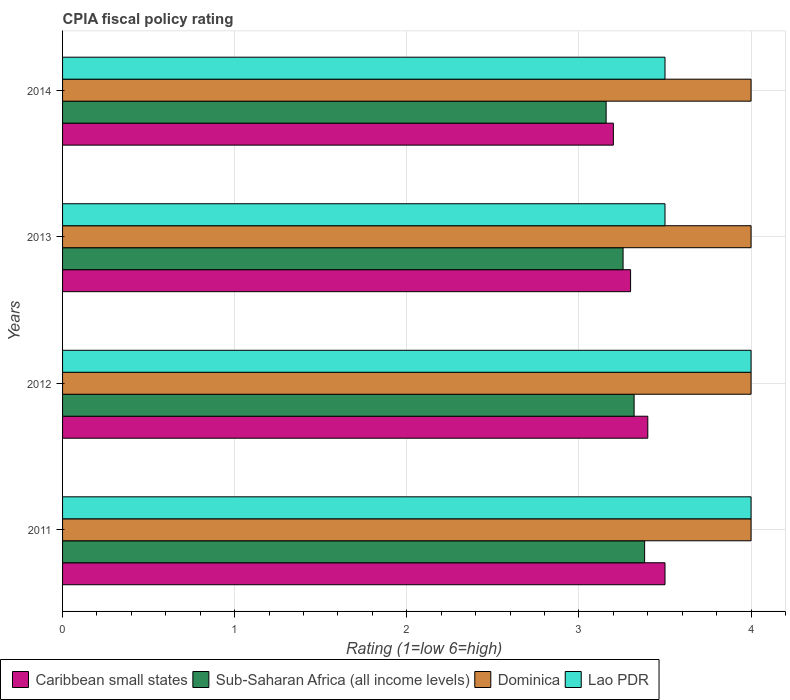How many different coloured bars are there?
Give a very brief answer. 4. Are the number of bars on each tick of the Y-axis equal?
Provide a succinct answer. Yes. How many bars are there on the 4th tick from the bottom?
Your response must be concise. 4. What is the CPIA rating in Sub-Saharan Africa (all income levels) in 2012?
Ensure brevity in your answer.  3.32. Across all years, what is the maximum CPIA rating in Lao PDR?
Your answer should be compact. 4. Across all years, what is the minimum CPIA rating in Dominica?
Your response must be concise. 4. In which year was the CPIA rating in Dominica minimum?
Keep it short and to the point. 2011. What is the difference between the CPIA rating in Caribbean small states in 2011 and that in 2013?
Give a very brief answer. 0.2. What is the difference between the CPIA rating in Caribbean small states in 2014 and the CPIA rating in Sub-Saharan Africa (all income levels) in 2013?
Provide a succinct answer. -0.06. In the year 2014, what is the difference between the CPIA rating in Lao PDR and CPIA rating in Caribbean small states?
Provide a succinct answer. 0.3. In how many years, is the CPIA rating in Lao PDR greater than 1.2 ?
Offer a very short reply. 4. What is the ratio of the CPIA rating in Caribbean small states in 2011 to that in 2013?
Your answer should be compact. 1.06. What is the difference between the highest and the second highest CPIA rating in Sub-Saharan Africa (all income levels)?
Provide a short and direct response. 0.06. Is the sum of the CPIA rating in Lao PDR in 2012 and 2014 greater than the maximum CPIA rating in Caribbean small states across all years?
Ensure brevity in your answer.  Yes. What does the 3rd bar from the top in 2013 represents?
Provide a succinct answer. Sub-Saharan Africa (all income levels). What does the 1st bar from the bottom in 2014 represents?
Ensure brevity in your answer.  Caribbean small states. How many bars are there?
Your answer should be very brief. 16. Does the graph contain any zero values?
Provide a succinct answer. No. Does the graph contain grids?
Offer a very short reply. Yes. How are the legend labels stacked?
Give a very brief answer. Horizontal. What is the title of the graph?
Your answer should be compact. CPIA fiscal policy rating. Does "Philippines" appear as one of the legend labels in the graph?
Your answer should be very brief. No. What is the Rating (1=low 6=high) of Sub-Saharan Africa (all income levels) in 2011?
Keep it short and to the point. 3.38. What is the Rating (1=low 6=high) in Sub-Saharan Africa (all income levels) in 2012?
Make the answer very short. 3.32. What is the Rating (1=low 6=high) in Sub-Saharan Africa (all income levels) in 2013?
Offer a terse response. 3.26. What is the Rating (1=low 6=high) in Dominica in 2013?
Your response must be concise. 4. What is the Rating (1=low 6=high) of Caribbean small states in 2014?
Provide a succinct answer. 3.2. What is the Rating (1=low 6=high) in Sub-Saharan Africa (all income levels) in 2014?
Your response must be concise. 3.16. What is the Rating (1=low 6=high) of Dominica in 2014?
Your response must be concise. 4. Across all years, what is the maximum Rating (1=low 6=high) of Caribbean small states?
Keep it short and to the point. 3.5. Across all years, what is the maximum Rating (1=low 6=high) of Sub-Saharan Africa (all income levels)?
Give a very brief answer. 3.38. Across all years, what is the maximum Rating (1=low 6=high) in Dominica?
Give a very brief answer. 4. Across all years, what is the maximum Rating (1=low 6=high) of Lao PDR?
Offer a very short reply. 4. Across all years, what is the minimum Rating (1=low 6=high) of Sub-Saharan Africa (all income levels)?
Make the answer very short. 3.16. Across all years, what is the minimum Rating (1=low 6=high) of Lao PDR?
Your response must be concise. 3.5. What is the total Rating (1=low 6=high) in Sub-Saharan Africa (all income levels) in the graph?
Give a very brief answer. 13.12. What is the total Rating (1=low 6=high) in Dominica in the graph?
Your answer should be very brief. 16. What is the total Rating (1=low 6=high) of Lao PDR in the graph?
Your response must be concise. 15. What is the difference between the Rating (1=low 6=high) of Caribbean small states in 2011 and that in 2012?
Offer a very short reply. 0.1. What is the difference between the Rating (1=low 6=high) of Sub-Saharan Africa (all income levels) in 2011 and that in 2012?
Provide a succinct answer. 0.06. What is the difference between the Rating (1=low 6=high) in Dominica in 2011 and that in 2012?
Your answer should be compact. 0. What is the difference between the Rating (1=low 6=high) in Sub-Saharan Africa (all income levels) in 2011 and that in 2013?
Give a very brief answer. 0.13. What is the difference between the Rating (1=low 6=high) in Dominica in 2011 and that in 2013?
Your answer should be compact. 0. What is the difference between the Rating (1=low 6=high) in Lao PDR in 2011 and that in 2013?
Offer a terse response. 0.5. What is the difference between the Rating (1=low 6=high) in Sub-Saharan Africa (all income levels) in 2011 and that in 2014?
Your answer should be compact. 0.22. What is the difference between the Rating (1=low 6=high) in Dominica in 2011 and that in 2014?
Make the answer very short. 0. What is the difference between the Rating (1=low 6=high) in Caribbean small states in 2012 and that in 2013?
Ensure brevity in your answer.  0.1. What is the difference between the Rating (1=low 6=high) of Sub-Saharan Africa (all income levels) in 2012 and that in 2013?
Offer a terse response. 0.06. What is the difference between the Rating (1=low 6=high) in Sub-Saharan Africa (all income levels) in 2012 and that in 2014?
Keep it short and to the point. 0.16. What is the difference between the Rating (1=low 6=high) of Sub-Saharan Africa (all income levels) in 2013 and that in 2014?
Provide a short and direct response. 0.1. What is the difference between the Rating (1=low 6=high) in Lao PDR in 2013 and that in 2014?
Offer a very short reply. 0. What is the difference between the Rating (1=low 6=high) of Caribbean small states in 2011 and the Rating (1=low 6=high) of Sub-Saharan Africa (all income levels) in 2012?
Give a very brief answer. 0.18. What is the difference between the Rating (1=low 6=high) in Caribbean small states in 2011 and the Rating (1=low 6=high) in Lao PDR in 2012?
Offer a very short reply. -0.5. What is the difference between the Rating (1=low 6=high) in Sub-Saharan Africa (all income levels) in 2011 and the Rating (1=low 6=high) in Dominica in 2012?
Offer a terse response. -0.62. What is the difference between the Rating (1=low 6=high) in Sub-Saharan Africa (all income levels) in 2011 and the Rating (1=low 6=high) in Lao PDR in 2012?
Your response must be concise. -0.62. What is the difference between the Rating (1=low 6=high) in Caribbean small states in 2011 and the Rating (1=low 6=high) in Sub-Saharan Africa (all income levels) in 2013?
Your answer should be very brief. 0.24. What is the difference between the Rating (1=low 6=high) in Caribbean small states in 2011 and the Rating (1=low 6=high) in Lao PDR in 2013?
Make the answer very short. 0. What is the difference between the Rating (1=low 6=high) of Sub-Saharan Africa (all income levels) in 2011 and the Rating (1=low 6=high) of Dominica in 2013?
Make the answer very short. -0.62. What is the difference between the Rating (1=low 6=high) in Sub-Saharan Africa (all income levels) in 2011 and the Rating (1=low 6=high) in Lao PDR in 2013?
Offer a terse response. -0.12. What is the difference between the Rating (1=low 6=high) in Caribbean small states in 2011 and the Rating (1=low 6=high) in Sub-Saharan Africa (all income levels) in 2014?
Ensure brevity in your answer.  0.34. What is the difference between the Rating (1=low 6=high) in Caribbean small states in 2011 and the Rating (1=low 6=high) in Lao PDR in 2014?
Give a very brief answer. 0. What is the difference between the Rating (1=low 6=high) of Sub-Saharan Africa (all income levels) in 2011 and the Rating (1=low 6=high) of Dominica in 2014?
Offer a very short reply. -0.62. What is the difference between the Rating (1=low 6=high) in Sub-Saharan Africa (all income levels) in 2011 and the Rating (1=low 6=high) in Lao PDR in 2014?
Provide a succinct answer. -0.12. What is the difference between the Rating (1=low 6=high) of Caribbean small states in 2012 and the Rating (1=low 6=high) of Sub-Saharan Africa (all income levels) in 2013?
Offer a terse response. 0.14. What is the difference between the Rating (1=low 6=high) of Caribbean small states in 2012 and the Rating (1=low 6=high) of Dominica in 2013?
Give a very brief answer. -0.6. What is the difference between the Rating (1=low 6=high) of Caribbean small states in 2012 and the Rating (1=low 6=high) of Lao PDR in 2013?
Ensure brevity in your answer.  -0.1. What is the difference between the Rating (1=low 6=high) of Sub-Saharan Africa (all income levels) in 2012 and the Rating (1=low 6=high) of Dominica in 2013?
Your answer should be compact. -0.68. What is the difference between the Rating (1=low 6=high) in Sub-Saharan Africa (all income levels) in 2012 and the Rating (1=low 6=high) in Lao PDR in 2013?
Give a very brief answer. -0.18. What is the difference between the Rating (1=low 6=high) in Dominica in 2012 and the Rating (1=low 6=high) in Lao PDR in 2013?
Make the answer very short. 0.5. What is the difference between the Rating (1=low 6=high) of Caribbean small states in 2012 and the Rating (1=low 6=high) of Sub-Saharan Africa (all income levels) in 2014?
Your answer should be compact. 0.24. What is the difference between the Rating (1=low 6=high) of Caribbean small states in 2012 and the Rating (1=low 6=high) of Lao PDR in 2014?
Your answer should be compact. -0.1. What is the difference between the Rating (1=low 6=high) of Sub-Saharan Africa (all income levels) in 2012 and the Rating (1=low 6=high) of Dominica in 2014?
Ensure brevity in your answer.  -0.68. What is the difference between the Rating (1=low 6=high) of Sub-Saharan Africa (all income levels) in 2012 and the Rating (1=low 6=high) of Lao PDR in 2014?
Your response must be concise. -0.18. What is the difference between the Rating (1=low 6=high) of Caribbean small states in 2013 and the Rating (1=low 6=high) of Sub-Saharan Africa (all income levels) in 2014?
Make the answer very short. 0.14. What is the difference between the Rating (1=low 6=high) in Caribbean small states in 2013 and the Rating (1=low 6=high) in Dominica in 2014?
Your answer should be very brief. -0.7. What is the difference between the Rating (1=low 6=high) of Caribbean small states in 2013 and the Rating (1=low 6=high) of Lao PDR in 2014?
Give a very brief answer. -0.2. What is the difference between the Rating (1=low 6=high) in Sub-Saharan Africa (all income levels) in 2013 and the Rating (1=low 6=high) in Dominica in 2014?
Your answer should be very brief. -0.74. What is the difference between the Rating (1=low 6=high) of Sub-Saharan Africa (all income levels) in 2013 and the Rating (1=low 6=high) of Lao PDR in 2014?
Keep it short and to the point. -0.24. What is the difference between the Rating (1=low 6=high) of Dominica in 2013 and the Rating (1=low 6=high) of Lao PDR in 2014?
Keep it short and to the point. 0.5. What is the average Rating (1=low 6=high) of Caribbean small states per year?
Make the answer very short. 3.35. What is the average Rating (1=low 6=high) of Sub-Saharan Africa (all income levels) per year?
Give a very brief answer. 3.28. What is the average Rating (1=low 6=high) in Lao PDR per year?
Offer a terse response. 3.75. In the year 2011, what is the difference between the Rating (1=low 6=high) in Caribbean small states and Rating (1=low 6=high) in Sub-Saharan Africa (all income levels)?
Keep it short and to the point. 0.12. In the year 2011, what is the difference between the Rating (1=low 6=high) of Sub-Saharan Africa (all income levels) and Rating (1=low 6=high) of Dominica?
Your answer should be very brief. -0.62. In the year 2011, what is the difference between the Rating (1=low 6=high) in Sub-Saharan Africa (all income levels) and Rating (1=low 6=high) in Lao PDR?
Keep it short and to the point. -0.62. In the year 2012, what is the difference between the Rating (1=low 6=high) in Caribbean small states and Rating (1=low 6=high) in Sub-Saharan Africa (all income levels)?
Offer a terse response. 0.08. In the year 2012, what is the difference between the Rating (1=low 6=high) in Caribbean small states and Rating (1=low 6=high) in Dominica?
Provide a succinct answer. -0.6. In the year 2012, what is the difference between the Rating (1=low 6=high) of Sub-Saharan Africa (all income levels) and Rating (1=low 6=high) of Dominica?
Provide a short and direct response. -0.68. In the year 2012, what is the difference between the Rating (1=low 6=high) in Sub-Saharan Africa (all income levels) and Rating (1=low 6=high) in Lao PDR?
Offer a terse response. -0.68. In the year 2012, what is the difference between the Rating (1=low 6=high) of Dominica and Rating (1=low 6=high) of Lao PDR?
Ensure brevity in your answer.  0. In the year 2013, what is the difference between the Rating (1=low 6=high) of Caribbean small states and Rating (1=low 6=high) of Sub-Saharan Africa (all income levels)?
Your answer should be compact. 0.04. In the year 2013, what is the difference between the Rating (1=low 6=high) in Caribbean small states and Rating (1=low 6=high) in Dominica?
Your answer should be very brief. -0.7. In the year 2013, what is the difference between the Rating (1=low 6=high) of Caribbean small states and Rating (1=low 6=high) of Lao PDR?
Offer a terse response. -0.2. In the year 2013, what is the difference between the Rating (1=low 6=high) in Sub-Saharan Africa (all income levels) and Rating (1=low 6=high) in Dominica?
Give a very brief answer. -0.74. In the year 2013, what is the difference between the Rating (1=low 6=high) in Sub-Saharan Africa (all income levels) and Rating (1=low 6=high) in Lao PDR?
Ensure brevity in your answer.  -0.24. In the year 2014, what is the difference between the Rating (1=low 6=high) in Caribbean small states and Rating (1=low 6=high) in Sub-Saharan Africa (all income levels)?
Offer a terse response. 0.04. In the year 2014, what is the difference between the Rating (1=low 6=high) of Caribbean small states and Rating (1=low 6=high) of Lao PDR?
Provide a succinct answer. -0.3. In the year 2014, what is the difference between the Rating (1=low 6=high) of Sub-Saharan Africa (all income levels) and Rating (1=low 6=high) of Dominica?
Offer a terse response. -0.84. In the year 2014, what is the difference between the Rating (1=low 6=high) in Sub-Saharan Africa (all income levels) and Rating (1=low 6=high) in Lao PDR?
Your answer should be compact. -0.34. What is the ratio of the Rating (1=low 6=high) of Caribbean small states in 2011 to that in 2012?
Keep it short and to the point. 1.03. What is the ratio of the Rating (1=low 6=high) in Sub-Saharan Africa (all income levels) in 2011 to that in 2012?
Provide a succinct answer. 1.02. What is the ratio of the Rating (1=low 6=high) in Dominica in 2011 to that in 2012?
Offer a terse response. 1. What is the ratio of the Rating (1=low 6=high) in Caribbean small states in 2011 to that in 2013?
Ensure brevity in your answer.  1.06. What is the ratio of the Rating (1=low 6=high) in Sub-Saharan Africa (all income levels) in 2011 to that in 2013?
Provide a succinct answer. 1.04. What is the ratio of the Rating (1=low 6=high) in Dominica in 2011 to that in 2013?
Ensure brevity in your answer.  1. What is the ratio of the Rating (1=low 6=high) of Lao PDR in 2011 to that in 2013?
Provide a short and direct response. 1.14. What is the ratio of the Rating (1=low 6=high) in Caribbean small states in 2011 to that in 2014?
Keep it short and to the point. 1.09. What is the ratio of the Rating (1=low 6=high) of Sub-Saharan Africa (all income levels) in 2011 to that in 2014?
Offer a very short reply. 1.07. What is the ratio of the Rating (1=low 6=high) in Dominica in 2011 to that in 2014?
Your response must be concise. 1. What is the ratio of the Rating (1=low 6=high) of Caribbean small states in 2012 to that in 2013?
Offer a very short reply. 1.03. What is the ratio of the Rating (1=low 6=high) of Sub-Saharan Africa (all income levels) in 2012 to that in 2013?
Offer a very short reply. 1.02. What is the ratio of the Rating (1=low 6=high) in Dominica in 2012 to that in 2013?
Keep it short and to the point. 1. What is the ratio of the Rating (1=low 6=high) of Lao PDR in 2012 to that in 2013?
Your answer should be very brief. 1.14. What is the ratio of the Rating (1=low 6=high) in Caribbean small states in 2012 to that in 2014?
Offer a very short reply. 1.06. What is the ratio of the Rating (1=low 6=high) in Sub-Saharan Africa (all income levels) in 2012 to that in 2014?
Keep it short and to the point. 1.05. What is the ratio of the Rating (1=low 6=high) in Dominica in 2012 to that in 2014?
Offer a terse response. 1. What is the ratio of the Rating (1=low 6=high) of Caribbean small states in 2013 to that in 2014?
Offer a terse response. 1.03. What is the ratio of the Rating (1=low 6=high) of Sub-Saharan Africa (all income levels) in 2013 to that in 2014?
Ensure brevity in your answer.  1.03. What is the ratio of the Rating (1=low 6=high) of Dominica in 2013 to that in 2014?
Your response must be concise. 1. What is the difference between the highest and the second highest Rating (1=low 6=high) in Caribbean small states?
Your response must be concise. 0.1. What is the difference between the highest and the second highest Rating (1=low 6=high) of Sub-Saharan Africa (all income levels)?
Offer a very short reply. 0.06. What is the difference between the highest and the second highest Rating (1=low 6=high) of Lao PDR?
Keep it short and to the point. 0. What is the difference between the highest and the lowest Rating (1=low 6=high) in Caribbean small states?
Offer a very short reply. 0.3. What is the difference between the highest and the lowest Rating (1=low 6=high) in Sub-Saharan Africa (all income levels)?
Your answer should be very brief. 0.22. What is the difference between the highest and the lowest Rating (1=low 6=high) in Dominica?
Provide a succinct answer. 0. What is the difference between the highest and the lowest Rating (1=low 6=high) of Lao PDR?
Your answer should be very brief. 0.5. 